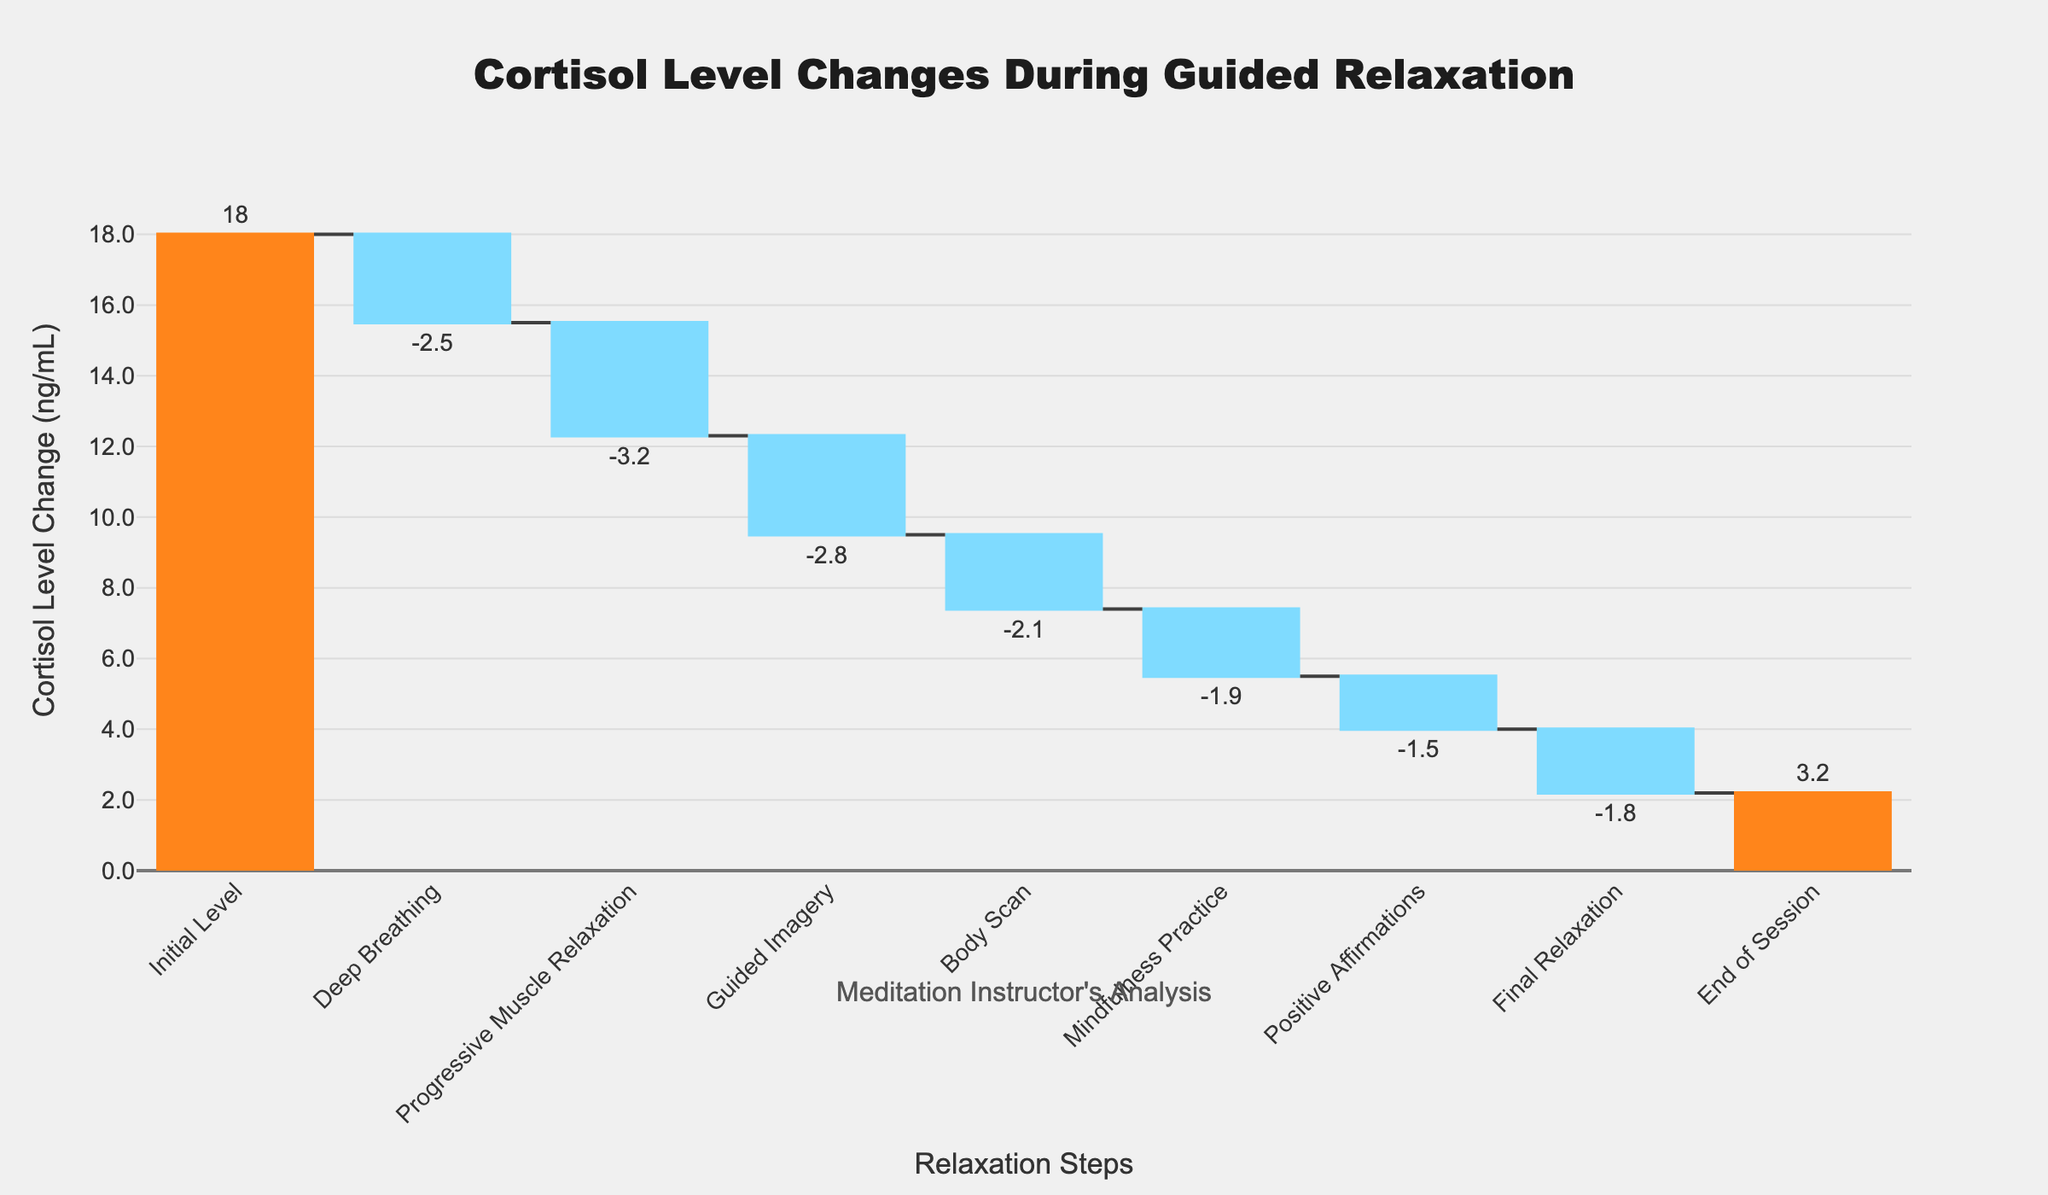What is the title of the waterfall chart? The title of a chart is usually prominently displayed at the top. In this case, it reads "Cortisol Level Changes During Guided Relaxation".
Answer: Cortisol Level Changes During Guided Relaxation What step corresponds to the greatest decrease in cortisol levels? To find the greatest decrease, you need to look at the "Cortisol Level Change (ng/mL)" values and identify the most negative value. Here, "Progressive Muscle Relaxation" shows -3.2 ng/mL.
Answer: Progressive Muscle Relaxation Which methods during the session led to an increase in cortisol levels? Positive increases in the data indicate an increase in cortisol levels. According to the chart, only "End of Session" shows a positive change of 3.2 ng/mL.
Answer: End of Session What is the cumulative cortisol level change by the end of the "Mindfulness Practice" step? To find the cumulative change, sum the cortisol level changes from "Initial Level" through "Mindfulness Practice." The sum of changes up to that point is: 18 + (-2.5) + (-3.2) + (-2.8) + (-2.1) + (-1.9) = 5.5.
Answer: 5.5 ng/mL Compare the efficacy of "Guided Imagery" and "Body Scan" in reducing cortisol levels. Which one was more effective? Compare the absolute values of the cortisol reduction for each step: "Guided Imagery" is -2.8 and "Body Scan" is -2.1. Since -2.8 is more negative than -2.1, "Guided Imagery" was more effective.
Answer: Guided Imagery What is the overall reduction in cortisol levels from the beginning to the "Final Relaxation" step, excluding the "End of Session"? Sum the reductions without including "End of Session": (-2.5) + (-3.2) + (-2.8) + (-2.1) + (-1.9) + (-1.5) + (-1.8) = -15.8
Answer: -15.8 ng/mL How many relaxation steps are shown in the chart? Count the number of data points or bars excluding the total bar at the end. There are 8 steps: "Initial Level," "Deep Breathing," "Progressive Muscle Relaxation," "Guided Imagery," "Body Scan," "Mindfulness Practice," "Positive Affirmations," and "Final Relaxation".
Answer: 8 Which step shows the least decrease in cortisol level? Look for the most minimal negative change in cortisol level. "Positive Affirmations" shows the least decrease at -1.5 ng/mL.
Answer: Positive Affirmations What are the colors used for indicating decreasing levels? Observe the bars depicting decreased cortisol levels; these are colored in a light blue shade.
Answer: Light blue 